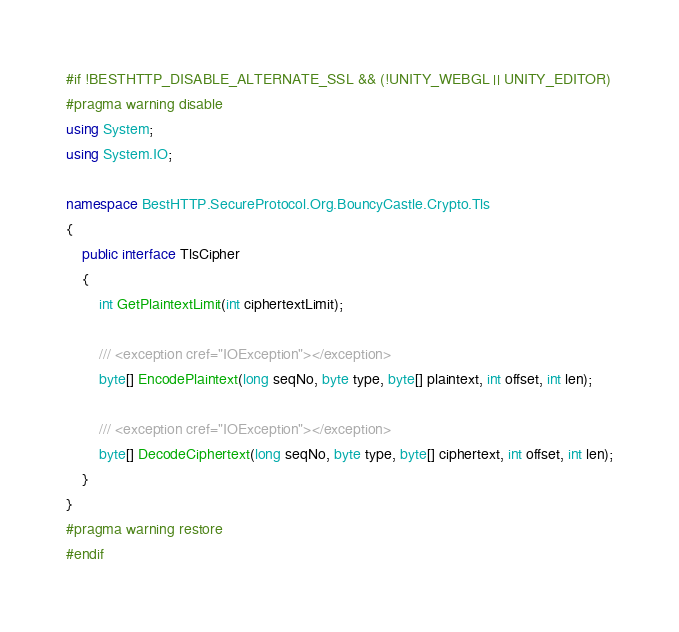<code> <loc_0><loc_0><loc_500><loc_500><_C#_>#if !BESTHTTP_DISABLE_ALTERNATE_SSL && (!UNITY_WEBGL || UNITY_EDITOR)
#pragma warning disable
using System;
using System.IO;

namespace BestHTTP.SecureProtocol.Org.BouncyCastle.Crypto.Tls
{
    public interface TlsCipher
    {
        int GetPlaintextLimit(int ciphertextLimit);

        /// <exception cref="IOException"></exception>
        byte[] EncodePlaintext(long seqNo, byte type, byte[] plaintext, int offset, int len);

        /// <exception cref="IOException"></exception>
        byte[] DecodeCiphertext(long seqNo, byte type, byte[] ciphertext, int offset, int len);
    }
}
#pragma warning restore
#endif
</code> 